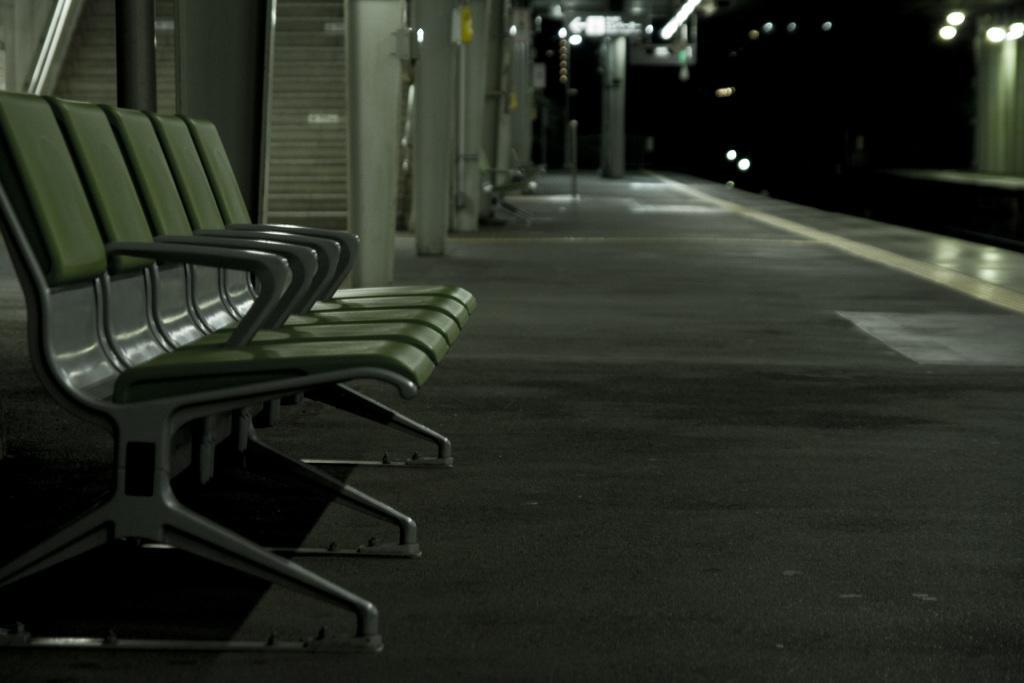In one or two sentences, can you explain what this image depicts? In this picture I can observe chairs on the left side. It is looking like a railway station. I can observe some lights on the right side. The background is completely dark. 